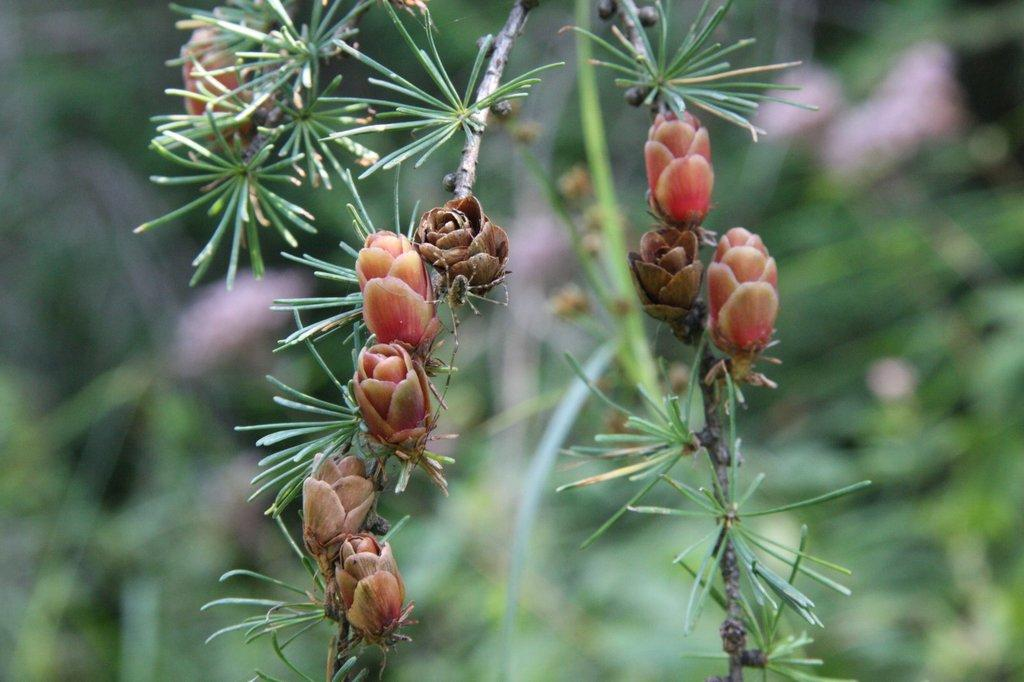Where was the image most likely taken? The image was likely clicked outside. What can be seen in the foreground of the image? There are stems and buds in the foreground of the image, along with other unspecified objects. Can you describe the background of the image? The background of the image is blurry. How much money can be seen in the image? There is no money visible in the image. What is the person in the image laughing at? There is no person present in the image, so it is not possible to determine what they might be laughing at. 